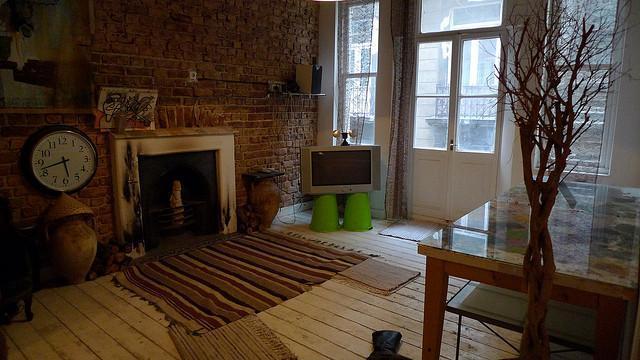How many trees do you see?
Give a very brief answer. 1. How many rooms are shown?
Give a very brief answer. 1. How many clocks do you see?
Give a very brief answer. 1. How many tables are empty?
Give a very brief answer. 1. How many red squares can you see on the rug?
Give a very brief answer. 0. How many crates are in  the photo?
Give a very brief answer. 0. How many houseplants are there?
Give a very brief answer. 1. How many numbers are there?
Give a very brief answer. 12. How many people in the photo appear to be children?
Give a very brief answer. 0. 